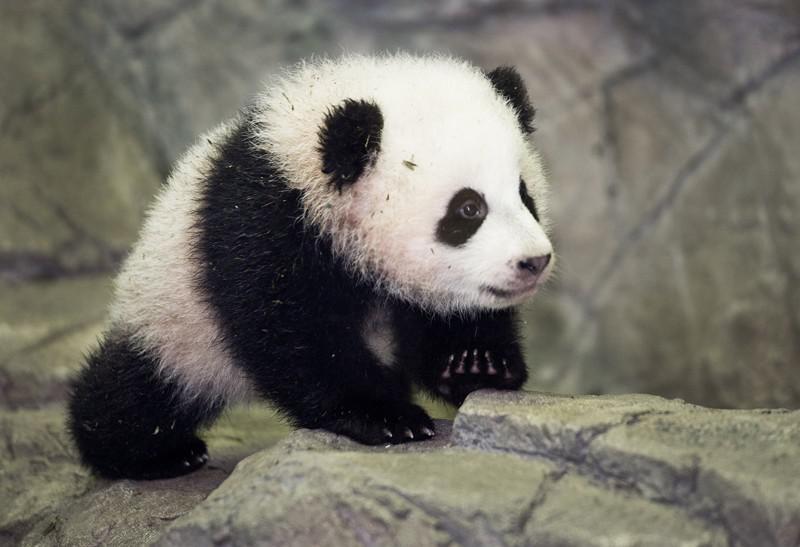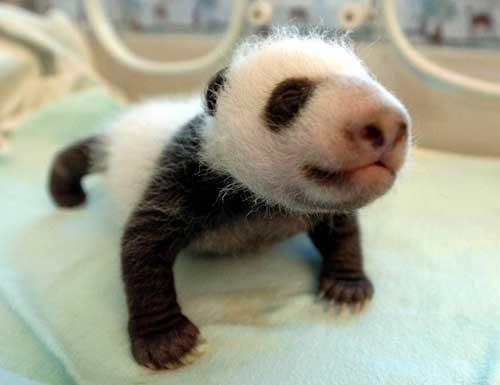The first image is the image on the left, the second image is the image on the right. Evaluate the accuracy of this statement regarding the images: "The right image shows a baby panda with a pink nose and fuzzy fur, posed on a blanket with the toes of two limbs turning inward.". Is it true? Answer yes or no. Yes. The first image is the image on the left, the second image is the image on the right. Evaluate the accuracy of this statement regarding the images: "The left and right image contains the same number of pandas.". Is it true? Answer yes or no. Yes. 